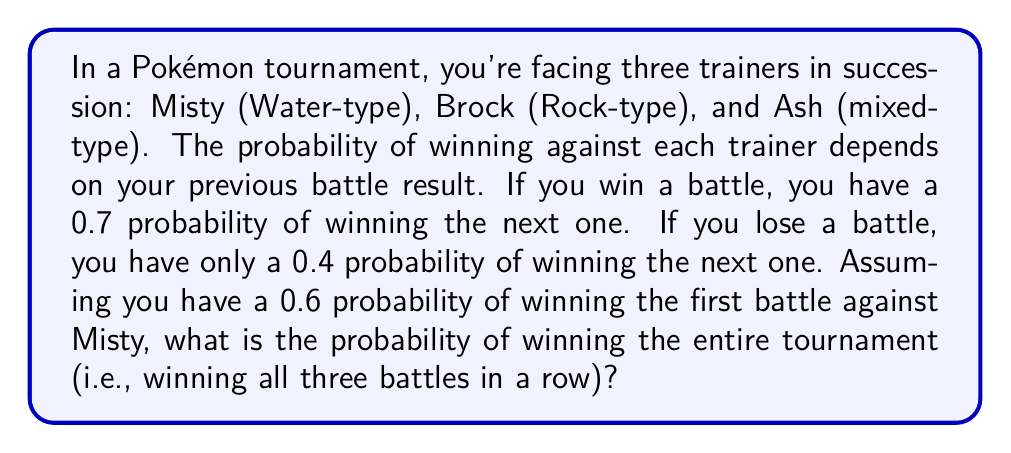What is the answer to this math problem? Let's approach this problem using Markov chains and transition probabilities:

1) First, let's define our states:
   W = Win, L = Lose

2) The transition matrix for this Markov chain is:

   $$P = \begin{bmatrix}
   0.7 & 0.3 \\
   0.4 & 0.6
   \end{bmatrix}$$

3) We start with the probability of winning against Misty:
   
   $$P(\text{Win against Misty}) = 0.6$$

4) Now, we need to calculate the probability of winning all three battles. This is a product of probabilities:

   $$P(\text{Win all}) = P(\text{Win Misty}) \times P(\text{Win Brock|Won Misty}) \times P(\text{Win Ash|Won Brock})$$

5) We know $P(\text{Win Misty}) = 0.6$

6) If we won against Misty, the probability of winning against Brock is 0.7:
   
   $$P(\text{Win Brock|Won Misty}) = 0.7$$

7) If we won against Brock (given we won against Misty), the probability of winning against Ash is also 0.7:
   
   $$P(\text{Win Ash|Won Brock}) = 0.7$$

8) Now we can multiply these probabilities:

   $$P(\text{Win all}) = 0.6 \times 0.7 \times 0.7 = 0.294$$

Therefore, the probability of winning all three battles in a row is 0.294 or 29.4%.
Answer: 0.294 